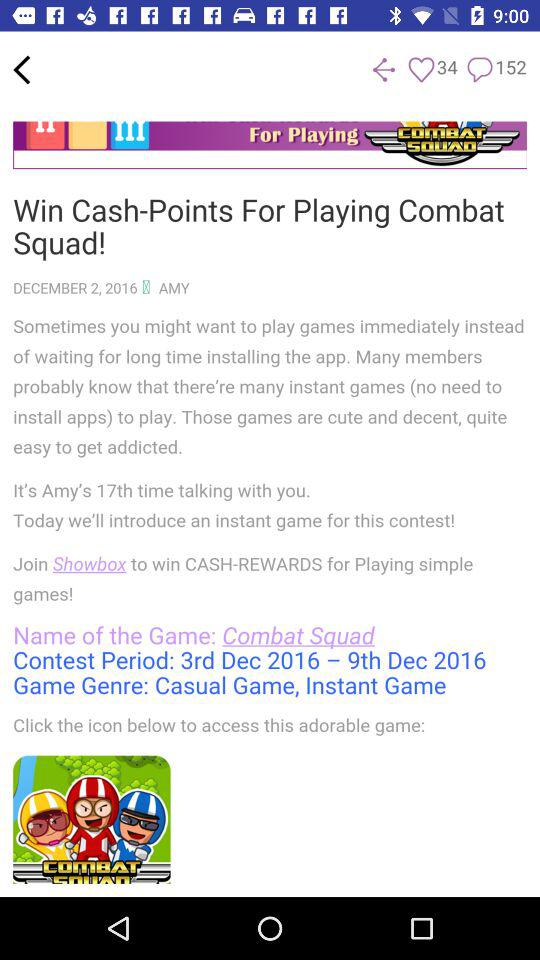What do we have to do to win cash-points? You have to play "Combat Squad" to win cash-points. 